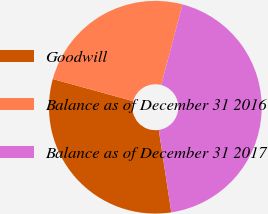Convert chart to OTSL. <chart><loc_0><loc_0><loc_500><loc_500><pie_chart><fcel>Goodwill<fcel>Balance as of December 31 2016<fcel>Balance as of December 31 2017<nl><fcel>31.67%<fcel>24.84%<fcel>43.49%<nl></chart> 